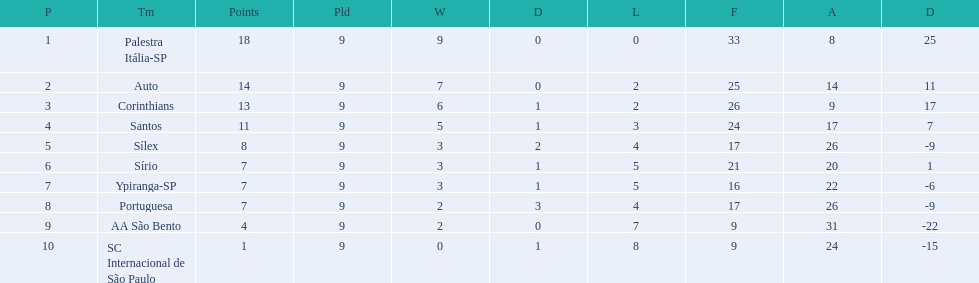How many points were scored by the teams? 18, 14, 13, 11, 8, 7, 7, 7, 4, 1. What team scored 13 points? Corinthians. 